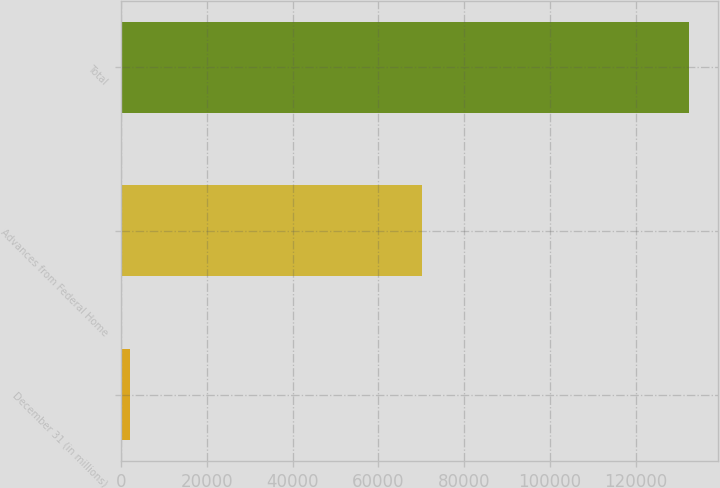<chart> <loc_0><loc_0><loc_500><loc_500><bar_chart><fcel>December 31 (in millions)<fcel>Advances from Federal Home<fcel>Total<nl><fcel>2008<fcel>70187<fcel>132400<nl></chart> 